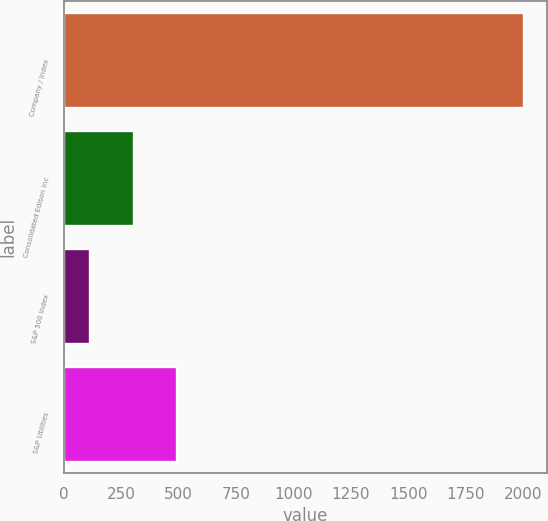Convert chart to OTSL. <chart><loc_0><loc_0><loc_500><loc_500><bar_chart><fcel>Company / Index<fcel>Consolidated Edison Inc<fcel>S&P 500 Index<fcel>S&P Utilities<nl><fcel>2005<fcel>305.2<fcel>116.33<fcel>494.07<nl></chart> 